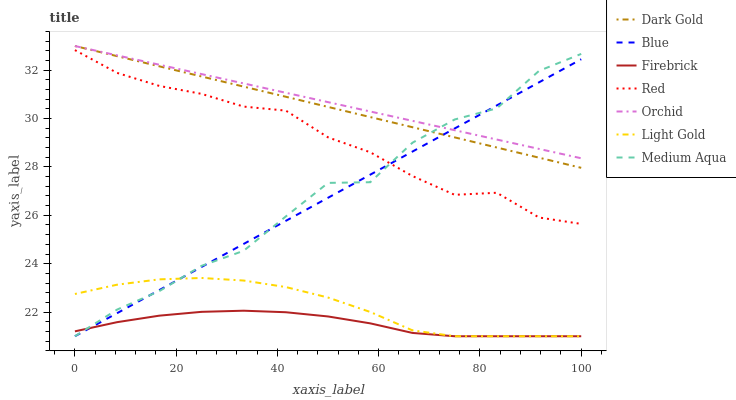Does Dark Gold have the minimum area under the curve?
Answer yes or no. No. Does Dark Gold have the maximum area under the curve?
Answer yes or no. No. Is Dark Gold the smoothest?
Answer yes or no. No. Is Dark Gold the roughest?
Answer yes or no. No. Does Dark Gold have the lowest value?
Answer yes or no. No. Does Firebrick have the highest value?
Answer yes or no. No. Is Light Gold less than Red?
Answer yes or no. Yes. Is Red greater than Firebrick?
Answer yes or no. Yes. Does Light Gold intersect Red?
Answer yes or no. No. 